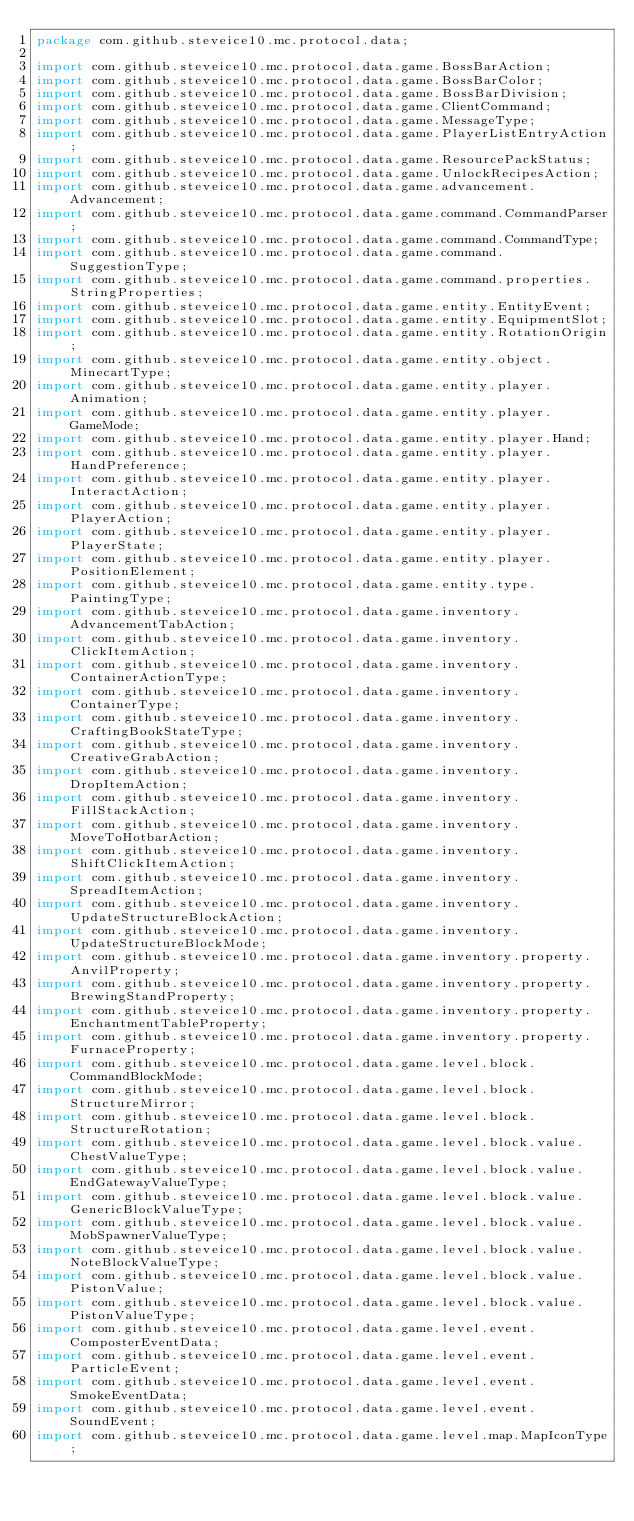<code> <loc_0><loc_0><loc_500><loc_500><_Java_>package com.github.steveice10.mc.protocol.data;

import com.github.steveice10.mc.protocol.data.game.BossBarAction;
import com.github.steveice10.mc.protocol.data.game.BossBarColor;
import com.github.steveice10.mc.protocol.data.game.BossBarDivision;
import com.github.steveice10.mc.protocol.data.game.ClientCommand;
import com.github.steveice10.mc.protocol.data.game.MessageType;
import com.github.steveice10.mc.protocol.data.game.PlayerListEntryAction;
import com.github.steveice10.mc.protocol.data.game.ResourcePackStatus;
import com.github.steveice10.mc.protocol.data.game.UnlockRecipesAction;
import com.github.steveice10.mc.protocol.data.game.advancement.Advancement;
import com.github.steveice10.mc.protocol.data.game.command.CommandParser;
import com.github.steveice10.mc.protocol.data.game.command.CommandType;
import com.github.steveice10.mc.protocol.data.game.command.SuggestionType;
import com.github.steveice10.mc.protocol.data.game.command.properties.StringProperties;
import com.github.steveice10.mc.protocol.data.game.entity.EntityEvent;
import com.github.steveice10.mc.protocol.data.game.entity.EquipmentSlot;
import com.github.steveice10.mc.protocol.data.game.entity.RotationOrigin;
import com.github.steveice10.mc.protocol.data.game.entity.object.MinecartType;
import com.github.steveice10.mc.protocol.data.game.entity.player.Animation;
import com.github.steveice10.mc.protocol.data.game.entity.player.GameMode;
import com.github.steveice10.mc.protocol.data.game.entity.player.Hand;
import com.github.steveice10.mc.protocol.data.game.entity.player.HandPreference;
import com.github.steveice10.mc.protocol.data.game.entity.player.InteractAction;
import com.github.steveice10.mc.protocol.data.game.entity.player.PlayerAction;
import com.github.steveice10.mc.protocol.data.game.entity.player.PlayerState;
import com.github.steveice10.mc.protocol.data.game.entity.player.PositionElement;
import com.github.steveice10.mc.protocol.data.game.entity.type.PaintingType;
import com.github.steveice10.mc.protocol.data.game.inventory.AdvancementTabAction;
import com.github.steveice10.mc.protocol.data.game.inventory.ClickItemAction;
import com.github.steveice10.mc.protocol.data.game.inventory.ContainerActionType;
import com.github.steveice10.mc.protocol.data.game.inventory.ContainerType;
import com.github.steveice10.mc.protocol.data.game.inventory.CraftingBookStateType;
import com.github.steveice10.mc.protocol.data.game.inventory.CreativeGrabAction;
import com.github.steveice10.mc.protocol.data.game.inventory.DropItemAction;
import com.github.steveice10.mc.protocol.data.game.inventory.FillStackAction;
import com.github.steveice10.mc.protocol.data.game.inventory.MoveToHotbarAction;
import com.github.steveice10.mc.protocol.data.game.inventory.ShiftClickItemAction;
import com.github.steveice10.mc.protocol.data.game.inventory.SpreadItemAction;
import com.github.steveice10.mc.protocol.data.game.inventory.UpdateStructureBlockAction;
import com.github.steveice10.mc.protocol.data.game.inventory.UpdateStructureBlockMode;
import com.github.steveice10.mc.protocol.data.game.inventory.property.AnvilProperty;
import com.github.steveice10.mc.protocol.data.game.inventory.property.BrewingStandProperty;
import com.github.steveice10.mc.protocol.data.game.inventory.property.EnchantmentTableProperty;
import com.github.steveice10.mc.protocol.data.game.inventory.property.FurnaceProperty;
import com.github.steveice10.mc.protocol.data.game.level.block.CommandBlockMode;
import com.github.steveice10.mc.protocol.data.game.level.block.StructureMirror;
import com.github.steveice10.mc.protocol.data.game.level.block.StructureRotation;
import com.github.steveice10.mc.protocol.data.game.level.block.value.ChestValueType;
import com.github.steveice10.mc.protocol.data.game.level.block.value.EndGatewayValueType;
import com.github.steveice10.mc.protocol.data.game.level.block.value.GenericBlockValueType;
import com.github.steveice10.mc.protocol.data.game.level.block.value.MobSpawnerValueType;
import com.github.steveice10.mc.protocol.data.game.level.block.value.NoteBlockValueType;
import com.github.steveice10.mc.protocol.data.game.level.block.value.PistonValue;
import com.github.steveice10.mc.protocol.data.game.level.block.value.PistonValueType;
import com.github.steveice10.mc.protocol.data.game.level.event.ComposterEventData;
import com.github.steveice10.mc.protocol.data.game.level.event.ParticleEvent;
import com.github.steveice10.mc.protocol.data.game.level.event.SmokeEventData;
import com.github.steveice10.mc.protocol.data.game.level.event.SoundEvent;
import com.github.steveice10.mc.protocol.data.game.level.map.MapIconType;</code> 